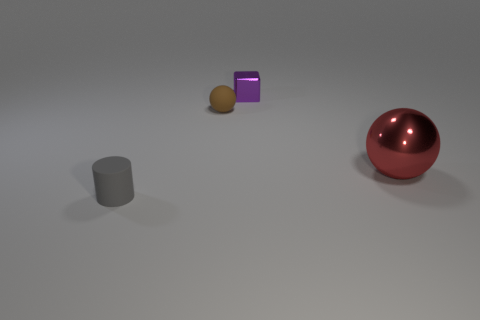What could be the purpose of creating this image? Images like this are likely created for the purpose of testing 3D rendering software, showcasing the effects of light and shadow on different shapes and materials, or practicing photorealistic modeling techniques. 